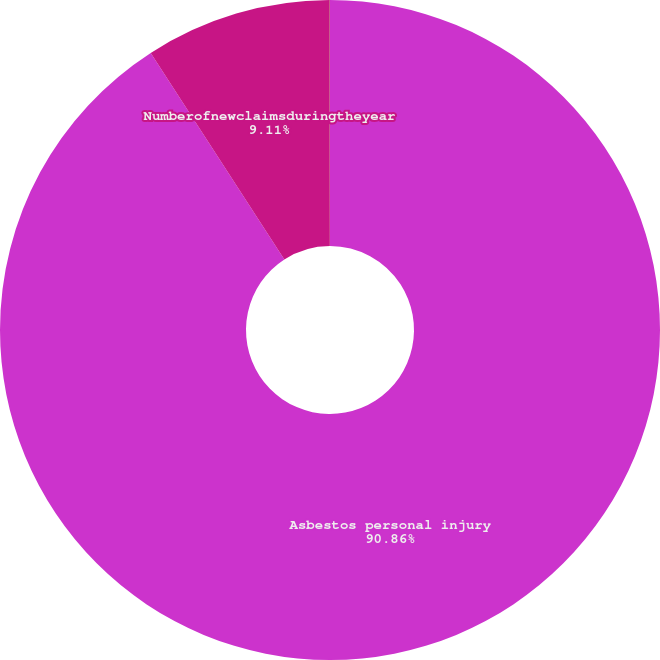<chart> <loc_0><loc_0><loc_500><loc_500><pie_chart><fcel>Asbestos personal injury<fcel>Numberofnewclaimsduringtheyear<fcel>Unnamed: 2<nl><fcel>90.85%<fcel>9.11%<fcel>0.03%<nl></chart> 